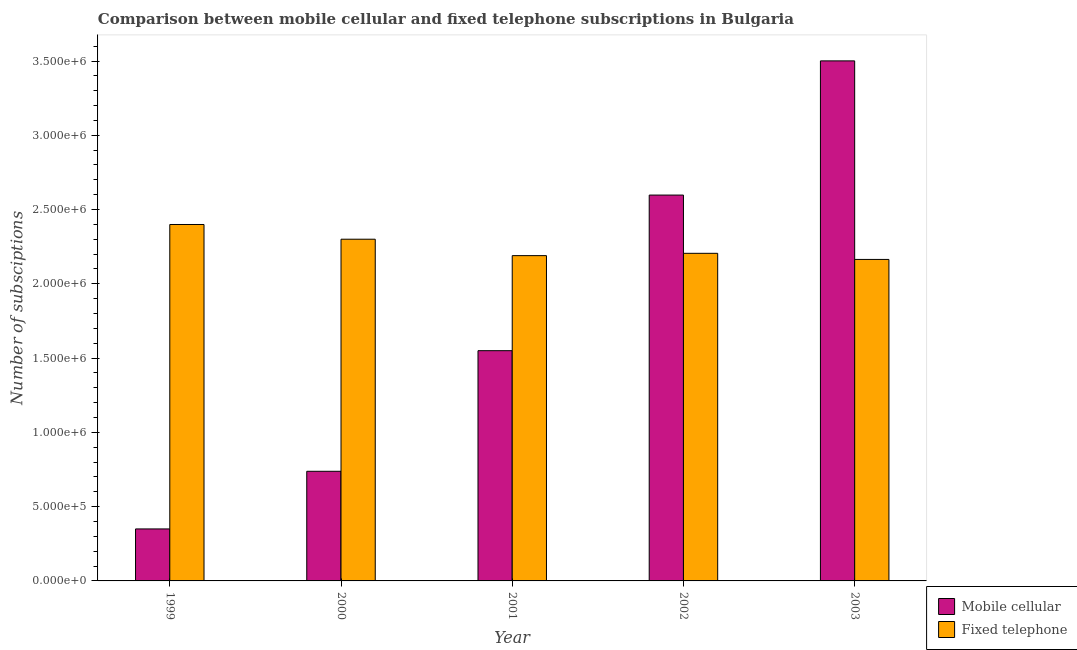How many different coloured bars are there?
Provide a short and direct response. 2. Are the number of bars on each tick of the X-axis equal?
Give a very brief answer. Yes. How many bars are there on the 4th tick from the left?
Offer a terse response. 2. How many bars are there on the 5th tick from the right?
Ensure brevity in your answer.  2. What is the number of mobile cellular subscriptions in 2000?
Offer a very short reply. 7.38e+05. Across all years, what is the maximum number of mobile cellular subscriptions?
Give a very brief answer. 3.50e+06. Across all years, what is the minimum number of mobile cellular subscriptions?
Give a very brief answer. 3.50e+05. What is the total number of mobile cellular subscriptions in the graph?
Provide a short and direct response. 8.74e+06. What is the difference between the number of mobile cellular subscriptions in 1999 and that in 2002?
Give a very brief answer. -2.25e+06. What is the difference between the number of mobile cellular subscriptions in 2000 and the number of fixed telephone subscriptions in 2002?
Provide a succinct answer. -1.86e+06. What is the average number of mobile cellular subscriptions per year?
Keep it short and to the point. 1.75e+06. What is the ratio of the number of mobile cellular subscriptions in 2000 to that in 2003?
Give a very brief answer. 0.21. Is the number of fixed telephone subscriptions in 1999 less than that in 2003?
Ensure brevity in your answer.  No. What is the difference between the highest and the second highest number of mobile cellular subscriptions?
Your response must be concise. 9.03e+05. What is the difference between the highest and the lowest number of fixed telephone subscriptions?
Give a very brief answer. 2.35e+05. What does the 2nd bar from the left in 2003 represents?
Keep it short and to the point. Fixed telephone. What does the 2nd bar from the right in 2003 represents?
Give a very brief answer. Mobile cellular. How many bars are there?
Provide a short and direct response. 10. How many years are there in the graph?
Your response must be concise. 5. Are the values on the major ticks of Y-axis written in scientific E-notation?
Offer a very short reply. Yes. How are the legend labels stacked?
Your answer should be very brief. Vertical. What is the title of the graph?
Your response must be concise. Comparison between mobile cellular and fixed telephone subscriptions in Bulgaria. What is the label or title of the Y-axis?
Offer a terse response. Number of subsciptions. What is the Number of subsciptions in Fixed telephone in 1999?
Keep it short and to the point. 2.40e+06. What is the Number of subsciptions in Mobile cellular in 2000?
Ensure brevity in your answer.  7.38e+05. What is the Number of subsciptions of Fixed telephone in 2000?
Offer a terse response. 2.30e+06. What is the Number of subsciptions of Mobile cellular in 2001?
Provide a short and direct response. 1.55e+06. What is the Number of subsciptions of Fixed telephone in 2001?
Your response must be concise. 2.19e+06. What is the Number of subsciptions of Mobile cellular in 2002?
Keep it short and to the point. 2.60e+06. What is the Number of subsciptions of Fixed telephone in 2002?
Provide a succinct answer. 2.21e+06. What is the Number of subsciptions of Mobile cellular in 2003?
Provide a succinct answer. 3.50e+06. What is the Number of subsciptions of Fixed telephone in 2003?
Your answer should be very brief. 2.16e+06. Across all years, what is the maximum Number of subsciptions in Mobile cellular?
Keep it short and to the point. 3.50e+06. Across all years, what is the maximum Number of subsciptions in Fixed telephone?
Offer a terse response. 2.40e+06. Across all years, what is the minimum Number of subsciptions of Fixed telephone?
Make the answer very short. 2.16e+06. What is the total Number of subsciptions in Mobile cellular in the graph?
Keep it short and to the point. 8.74e+06. What is the total Number of subsciptions of Fixed telephone in the graph?
Provide a short and direct response. 1.13e+07. What is the difference between the Number of subsciptions in Mobile cellular in 1999 and that in 2000?
Your response must be concise. -3.88e+05. What is the difference between the Number of subsciptions of Fixed telephone in 1999 and that in 2000?
Your response must be concise. 9.91e+04. What is the difference between the Number of subsciptions in Mobile cellular in 1999 and that in 2001?
Give a very brief answer. -1.20e+06. What is the difference between the Number of subsciptions of Fixed telephone in 1999 and that in 2001?
Give a very brief answer. 2.10e+05. What is the difference between the Number of subsciptions of Mobile cellular in 1999 and that in 2002?
Your response must be concise. -2.25e+06. What is the difference between the Number of subsciptions of Fixed telephone in 1999 and that in 2002?
Your response must be concise. 1.94e+05. What is the difference between the Number of subsciptions in Mobile cellular in 1999 and that in 2003?
Offer a terse response. -3.15e+06. What is the difference between the Number of subsciptions in Fixed telephone in 1999 and that in 2003?
Your answer should be compact. 2.35e+05. What is the difference between the Number of subsciptions of Mobile cellular in 2000 and that in 2001?
Make the answer very short. -8.12e+05. What is the difference between the Number of subsciptions in Fixed telephone in 2000 and that in 2001?
Give a very brief answer. 1.11e+05. What is the difference between the Number of subsciptions in Mobile cellular in 2000 and that in 2002?
Your answer should be very brief. -1.86e+06. What is the difference between the Number of subsciptions of Fixed telephone in 2000 and that in 2002?
Ensure brevity in your answer.  9.50e+04. What is the difference between the Number of subsciptions in Mobile cellular in 2000 and that in 2003?
Offer a very short reply. -2.76e+06. What is the difference between the Number of subsciptions of Fixed telephone in 2000 and that in 2003?
Offer a very short reply. 1.36e+05. What is the difference between the Number of subsciptions in Mobile cellular in 2001 and that in 2002?
Make the answer very short. -1.05e+06. What is the difference between the Number of subsciptions in Fixed telephone in 2001 and that in 2002?
Ensure brevity in your answer.  -1.56e+04. What is the difference between the Number of subsciptions of Mobile cellular in 2001 and that in 2003?
Give a very brief answer. -1.95e+06. What is the difference between the Number of subsciptions of Fixed telephone in 2001 and that in 2003?
Provide a short and direct response. 2.55e+04. What is the difference between the Number of subsciptions of Mobile cellular in 2002 and that in 2003?
Keep it short and to the point. -9.03e+05. What is the difference between the Number of subsciptions in Fixed telephone in 2002 and that in 2003?
Make the answer very short. 4.11e+04. What is the difference between the Number of subsciptions of Mobile cellular in 1999 and the Number of subsciptions of Fixed telephone in 2000?
Provide a short and direct response. -1.95e+06. What is the difference between the Number of subsciptions in Mobile cellular in 1999 and the Number of subsciptions in Fixed telephone in 2001?
Ensure brevity in your answer.  -1.84e+06. What is the difference between the Number of subsciptions in Mobile cellular in 1999 and the Number of subsciptions in Fixed telephone in 2002?
Offer a very short reply. -1.86e+06. What is the difference between the Number of subsciptions in Mobile cellular in 1999 and the Number of subsciptions in Fixed telephone in 2003?
Your answer should be compact. -1.81e+06. What is the difference between the Number of subsciptions of Mobile cellular in 2000 and the Number of subsciptions of Fixed telephone in 2001?
Your response must be concise. -1.45e+06. What is the difference between the Number of subsciptions in Mobile cellular in 2000 and the Number of subsciptions in Fixed telephone in 2002?
Make the answer very short. -1.47e+06. What is the difference between the Number of subsciptions in Mobile cellular in 2000 and the Number of subsciptions in Fixed telephone in 2003?
Provide a short and direct response. -1.43e+06. What is the difference between the Number of subsciptions of Mobile cellular in 2001 and the Number of subsciptions of Fixed telephone in 2002?
Your answer should be very brief. -6.55e+05. What is the difference between the Number of subsciptions in Mobile cellular in 2001 and the Number of subsciptions in Fixed telephone in 2003?
Make the answer very short. -6.14e+05. What is the difference between the Number of subsciptions of Mobile cellular in 2002 and the Number of subsciptions of Fixed telephone in 2003?
Give a very brief answer. 4.33e+05. What is the average Number of subsciptions in Mobile cellular per year?
Ensure brevity in your answer.  1.75e+06. What is the average Number of subsciptions in Fixed telephone per year?
Offer a terse response. 2.25e+06. In the year 1999, what is the difference between the Number of subsciptions of Mobile cellular and Number of subsciptions of Fixed telephone?
Offer a very short reply. -2.05e+06. In the year 2000, what is the difference between the Number of subsciptions of Mobile cellular and Number of subsciptions of Fixed telephone?
Your answer should be very brief. -1.56e+06. In the year 2001, what is the difference between the Number of subsciptions of Mobile cellular and Number of subsciptions of Fixed telephone?
Your answer should be compact. -6.40e+05. In the year 2002, what is the difference between the Number of subsciptions of Mobile cellular and Number of subsciptions of Fixed telephone?
Give a very brief answer. 3.92e+05. In the year 2003, what is the difference between the Number of subsciptions of Mobile cellular and Number of subsciptions of Fixed telephone?
Your answer should be compact. 1.34e+06. What is the ratio of the Number of subsciptions in Mobile cellular in 1999 to that in 2000?
Make the answer very short. 0.47. What is the ratio of the Number of subsciptions of Fixed telephone in 1999 to that in 2000?
Offer a very short reply. 1.04. What is the ratio of the Number of subsciptions of Mobile cellular in 1999 to that in 2001?
Give a very brief answer. 0.23. What is the ratio of the Number of subsciptions of Fixed telephone in 1999 to that in 2001?
Ensure brevity in your answer.  1.1. What is the ratio of the Number of subsciptions of Mobile cellular in 1999 to that in 2002?
Keep it short and to the point. 0.13. What is the ratio of the Number of subsciptions in Fixed telephone in 1999 to that in 2002?
Your answer should be compact. 1.09. What is the ratio of the Number of subsciptions of Fixed telephone in 1999 to that in 2003?
Ensure brevity in your answer.  1.11. What is the ratio of the Number of subsciptions of Mobile cellular in 2000 to that in 2001?
Your response must be concise. 0.48. What is the ratio of the Number of subsciptions of Fixed telephone in 2000 to that in 2001?
Make the answer very short. 1.05. What is the ratio of the Number of subsciptions of Mobile cellular in 2000 to that in 2002?
Make the answer very short. 0.28. What is the ratio of the Number of subsciptions in Fixed telephone in 2000 to that in 2002?
Your answer should be compact. 1.04. What is the ratio of the Number of subsciptions of Mobile cellular in 2000 to that in 2003?
Provide a short and direct response. 0.21. What is the ratio of the Number of subsciptions in Fixed telephone in 2000 to that in 2003?
Ensure brevity in your answer.  1.06. What is the ratio of the Number of subsciptions in Mobile cellular in 2001 to that in 2002?
Provide a short and direct response. 0.6. What is the ratio of the Number of subsciptions in Mobile cellular in 2001 to that in 2003?
Your response must be concise. 0.44. What is the ratio of the Number of subsciptions in Fixed telephone in 2001 to that in 2003?
Keep it short and to the point. 1.01. What is the ratio of the Number of subsciptions of Mobile cellular in 2002 to that in 2003?
Provide a short and direct response. 0.74. What is the difference between the highest and the second highest Number of subsciptions in Mobile cellular?
Keep it short and to the point. 9.03e+05. What is the difference between the highest and the second highest Number of subsciptions in Fixed telephone?
Give a very brief answer. 9.91e+04. What is the difference between the highest and the lowest Number of subsciptions of Mobile cellular?
Provide a succinct answer. 3.15e+06. What is the difference between the highest and the lowest Number of subsciptions of Fixed telephone?
Your answer should be very brief. 2.35e+05. 